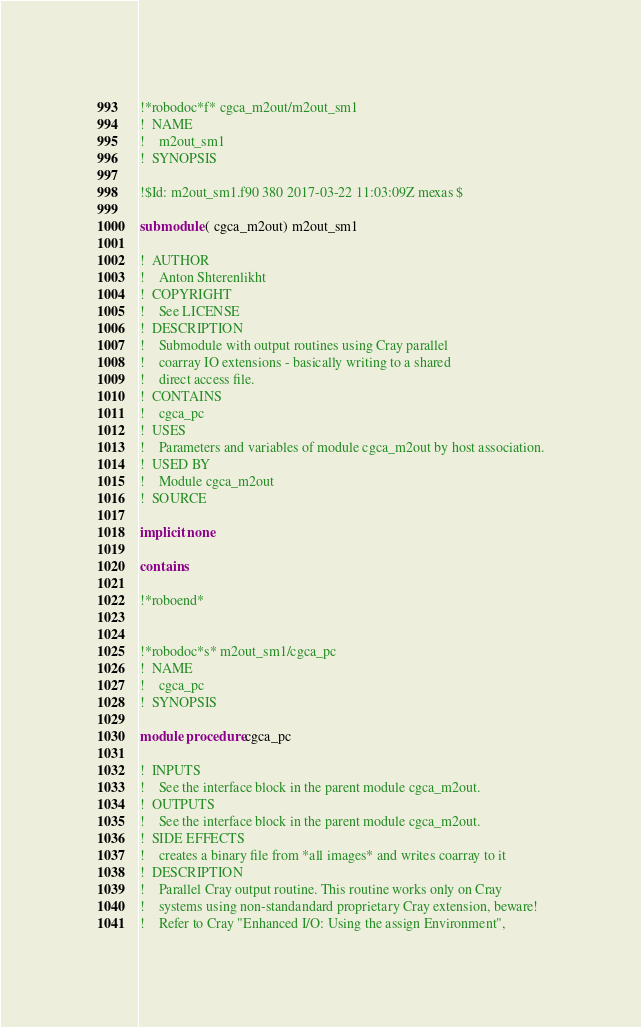<code> <loc_0><loc_0><loc_500><loc_500><_FORTRAN_>!*robodoc*f* cgca_m2out/m2out_sm1
!  NAME
!    m2out_sm1
!  SYNOPSIS

!$Id: m2out_sm1.f90 380 2017-03-22 11:03:09Z mexas $

submodule ( cgca_m2out) m2out_sm1

!  AUTHOR
!    Anton Shterenlikht
!  COPYRIGHT
!    See LICENSE
!  DESCRIPTION
!    Submodule with output routines using Cray parallel
!    coarray IO extensions - basically writing to a shared
!    direct access file.
!  CONTAINS
!    cgca_pc
!  USES
!    Parameters and variables of module cgca_m2out by host association.
!  USED BY
!    Module cgca_m2out
!  SOURCE

implicit none

contains

!*roboend*


!*robodoc*s* m2out_sm1/cgca_pc
!  NAME
!    cgca_pc
!  SYNOPSIS
 
module procedure cgca_pc

!  INPUTS
!    See the interface block in the parent module cgca_m2out.
!  OUTPUTS
!    See the interface block in the parent module cgca_m2out.
!  SIDE EFFECTS
!    creates a binary file from *all images* and writes coarray to it
!  DESCRIPTION
!    Parallel Cray output routine. This routine works only on Cray
!    systems using non-standandard proprietary Cray extension, beware!
!    Refer to Cray "Enhanced I/O: Using the assign Environment",</code> 